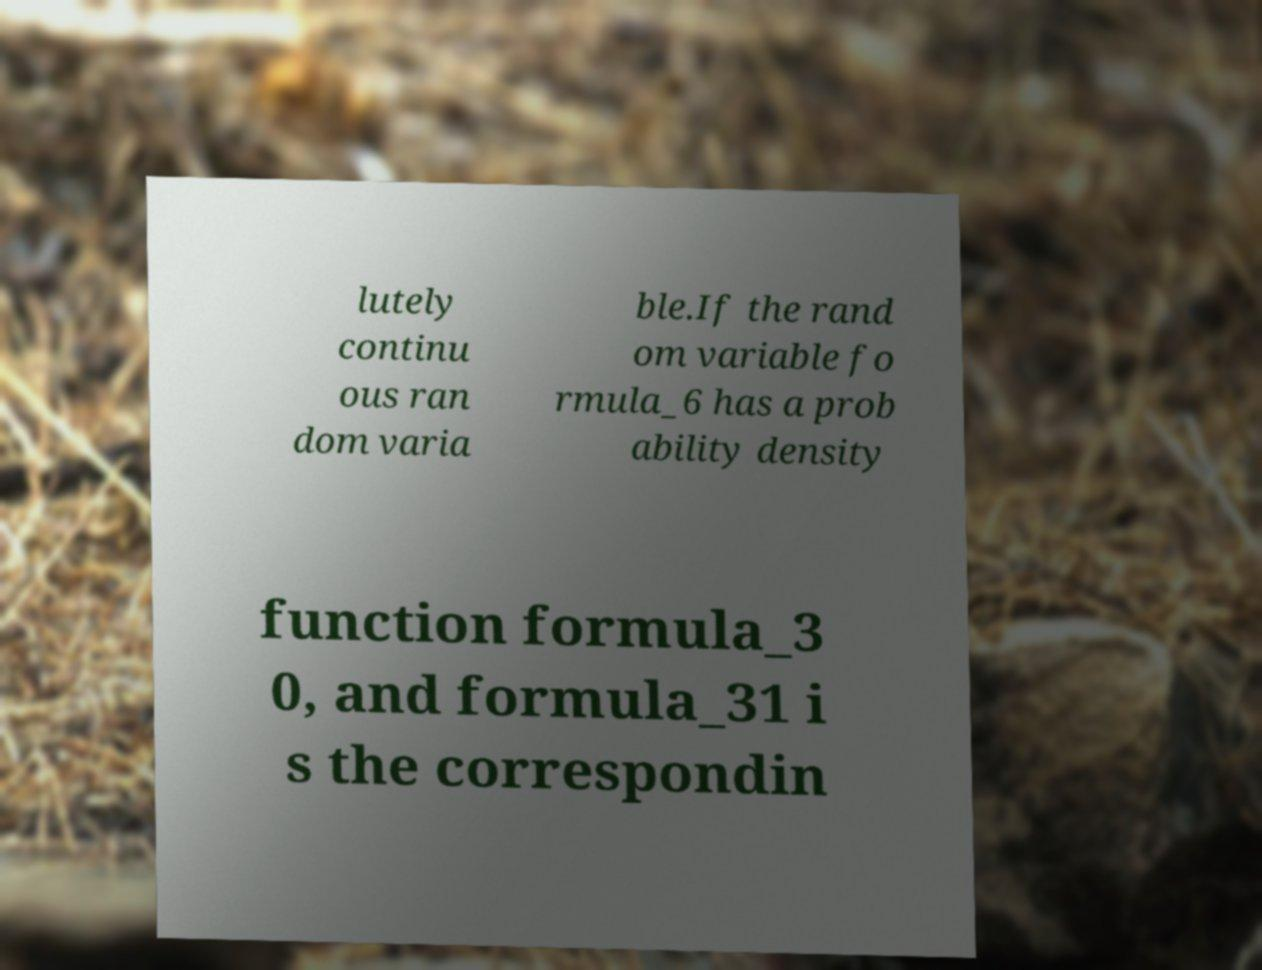Can you read and provide the text displayed in the image?This photo seems to have some interesting text. Can you extract and type it out for me? lutely continu ous ran dom varia ble.If the rand om variable fo rmula_6 has a prob ability density function formula_3 0, and formula_31 i s the correspondin 